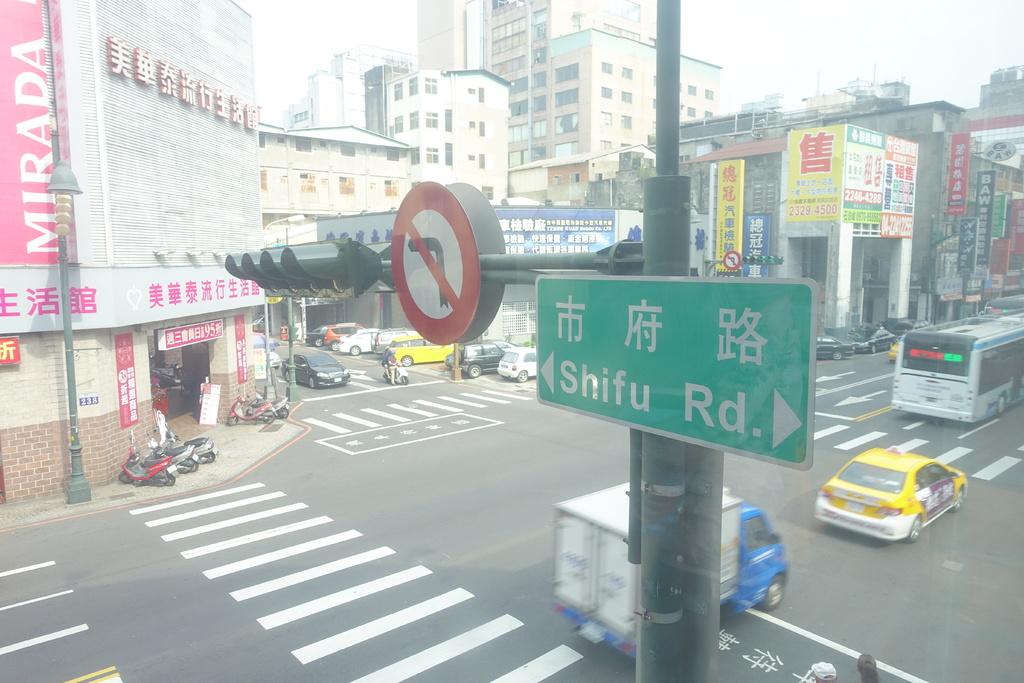What road is this?
Keep it short and to the point. Shifu. What is written on the red banner?
Make the answer very short. Mirada. 